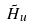Convert formula to latex. <formula><loc_0><loc_0><loc_500><loc_500>\tilde { H } _ { u }</formula> 